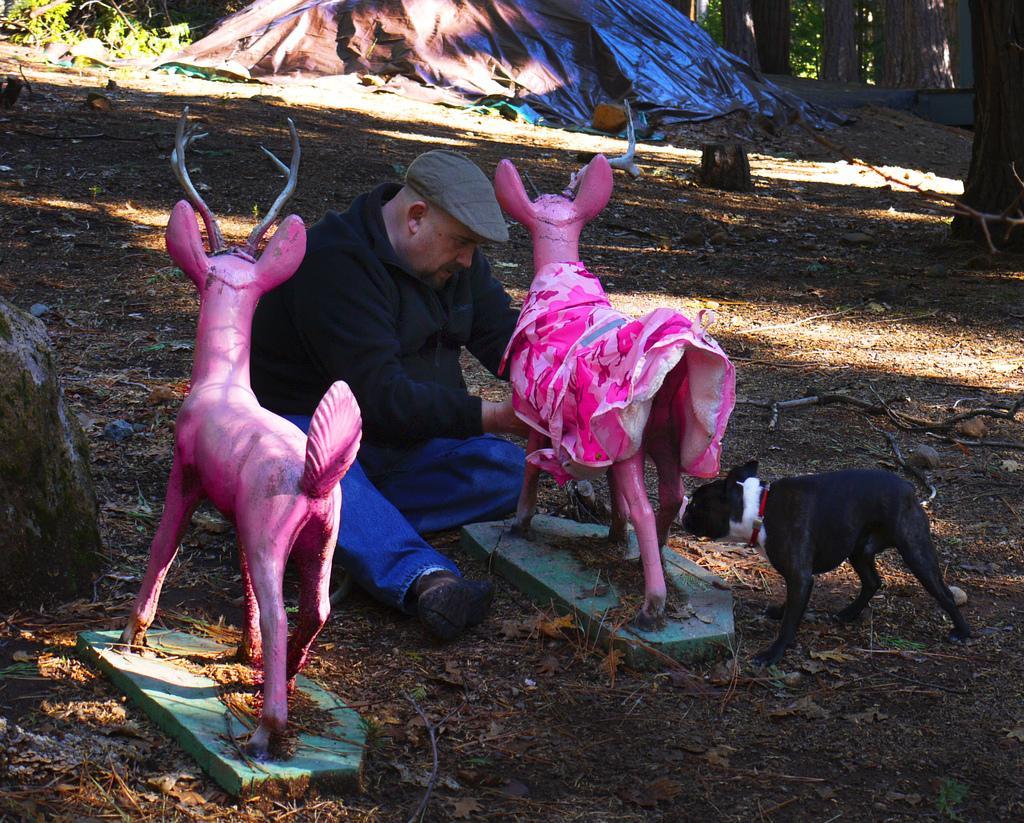In one or two sentences, can you explain what this image depicts? In this image, in the middle, we can see a man sitting on the land and holding a toy animal in his hand. On the right side, we can see an animal which is in black color. On the left side, we can also see a toy animal. In the background, we can see some trees, tent. At the bottom, we can see a land with some stones. 